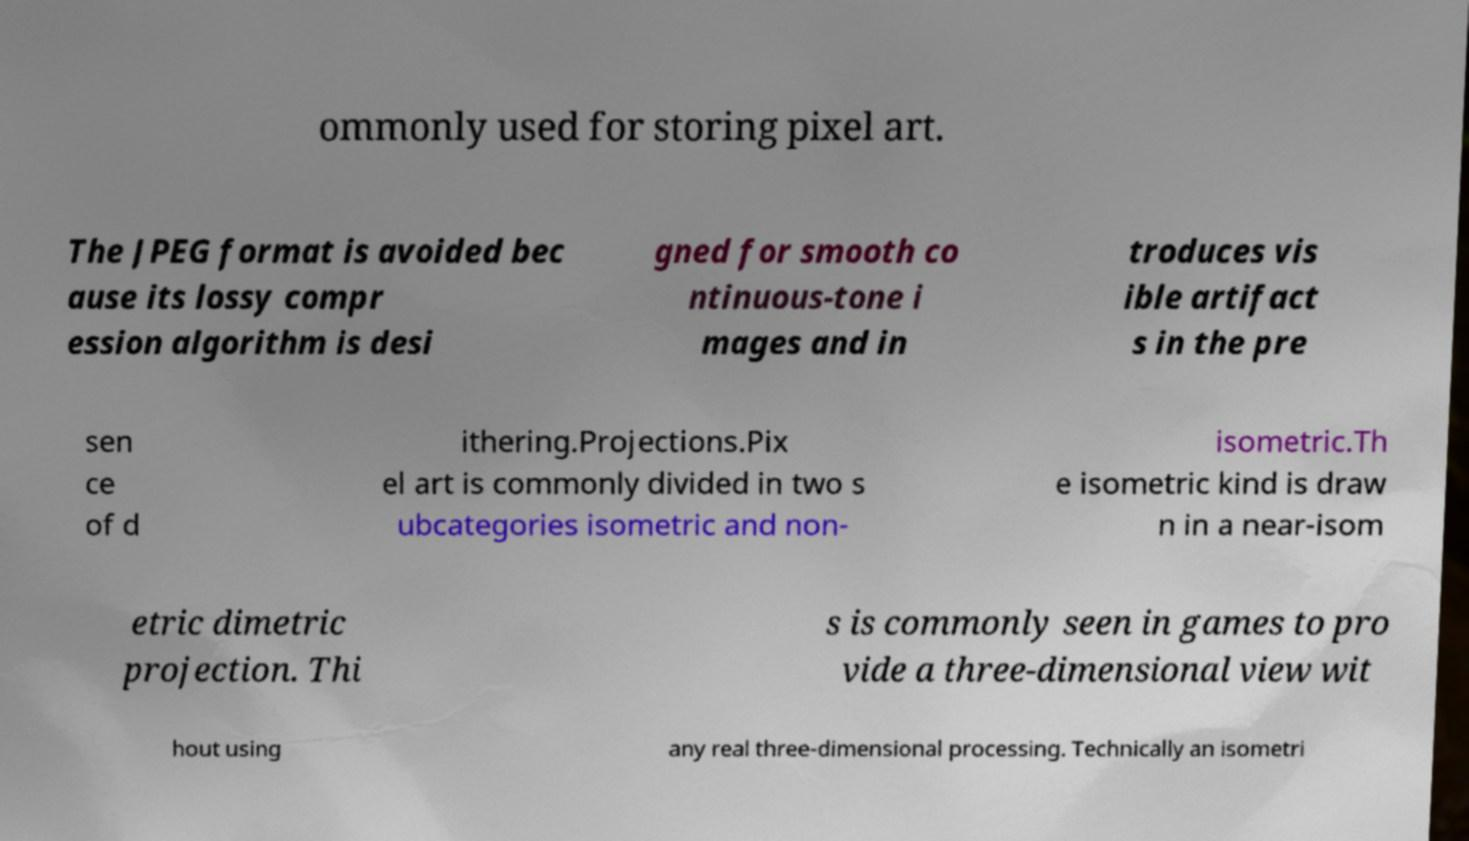Could you assist in decoding the text presented in this image and type it out clearly? ommonly used for storing pixel art. The JPEG format is avoided bec ause its lossy compr ession algorithm is desi gned for smooth co ntinuous-tone i mages and in troduces vis ible artifact s in the pre sen ce of d ithering.Projections.Pix el art is commonly divided in two s ubcategories isometric and non- isometric.Th e isometric kind is draw n in a near-isom etric dimetric projection. Thi s is commonly seen in games to pro vide a three-dimensional view wit hout using any real three-dimensional processing. Technically an isometri 